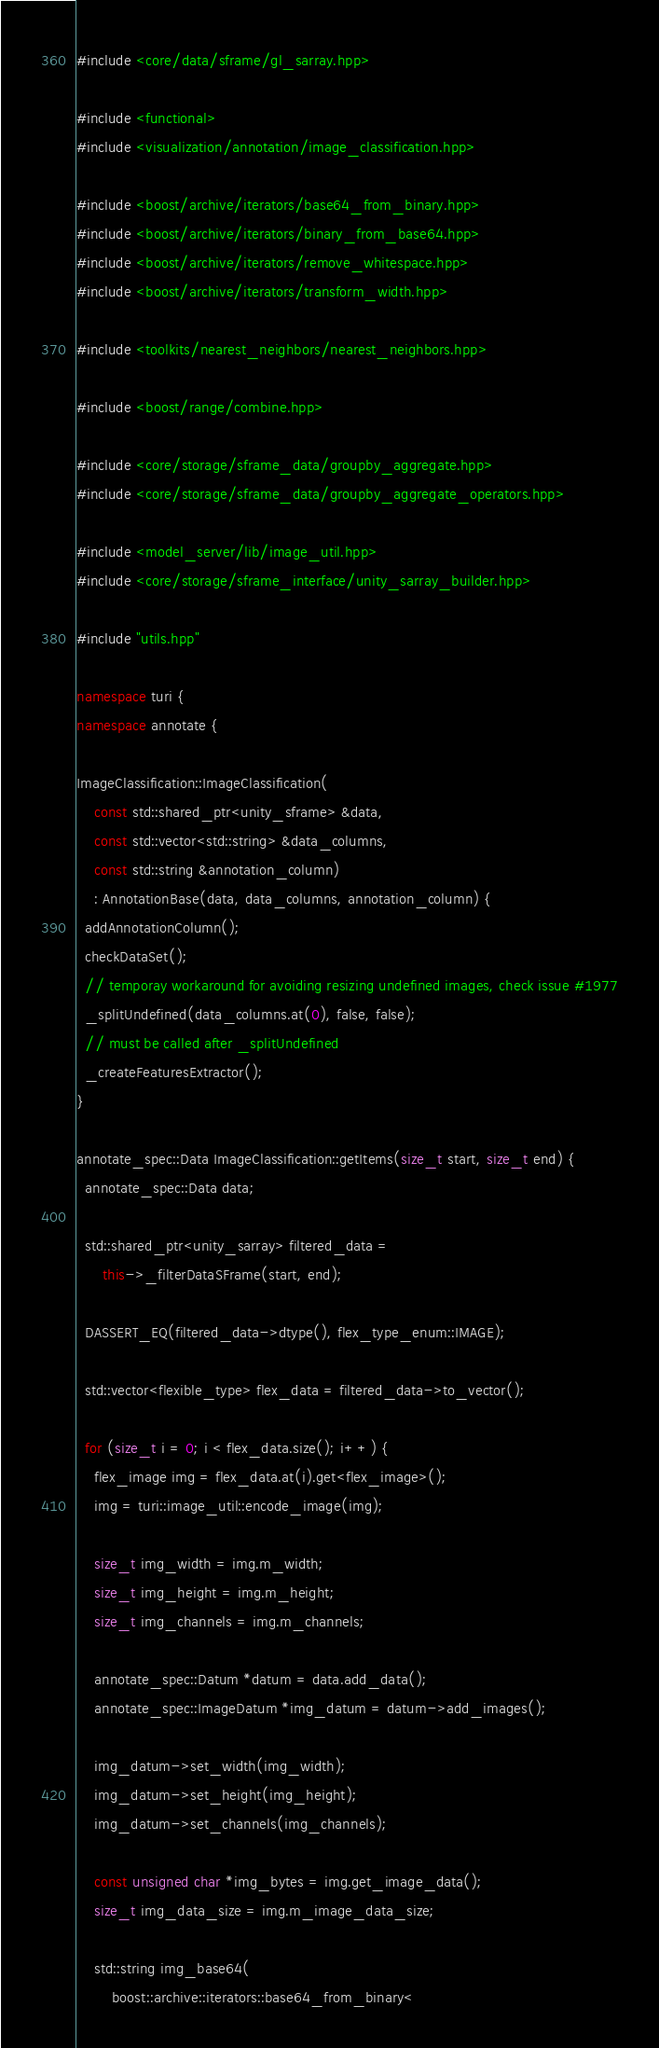Convert code to text. <code><loc_0><loc_0><loc_500><loc_500><_C++_>#include <core/data/sframe/gl_sarray.hpp>

#include <functional>
#include <visualization/annotation/image_classification.hpp>

#include <boost/archive/iterators/base64_from_binary.hpp>
#include <boost/archive/iterators/binary_from_base64.hpp>
#include <boost/archive/iterators/remove_whitespace.hpp>
#include <boost/archive/iterators/transform_width.hpp>

#include <toolkits/nearest_neighbors/nearest_neighbors.hpp>

#include <boost/range/combine.hpp>

#include <core/storage/sframe_data/groupby_aggregate.hpp>
#include <core/storage/sframe_data/groupby_aggregate_operators.hpp>

#include <model_server/lib/image_util.hpp>
#include <core/storage/sframe_interface/unity_sarray_builder.hpp>

#include "utils.hpp"

namespace turi {
namespace annotate {

ImageClassification::ImageClassification(
    const std::shared_ptr<unity_sframe> &data,
    const std::vector<std::string> &data_columns,
    const std::string &annotation_column)
    : AnnotationBase(data, data_columns, annotation_column) {
  addAnnotationColumn();
  checkDataSet();
  // temporay workaround for avoiding resizing undefined images, check issue #1977
  _splitUndefined(data_columns.at(0), false, false);
  // must be called after _splitUndefined
  _createFeaturesExtractor();
}

annotate_spec::Data ImageClassification::getItems(size_t start, size_t end) {
  annotate_spec::Data data;

  std::shared_ptr<unity_sarray> filtered_data =
      this->_filterDataSFrame(start, end);

  DASSERT_EQ(filtered_data->dtype(), flex_type_enum::IMAGE);

  std::vector<flexible_type> flex_data = filtered_data->to_vector();

  for (size_t i = 0; i < flex_data.size(); i++) {
    flex_image img = flex_data.at(i).get<flex_image>();
    img = turi::image_util::encode_image(img);

    size_t img_width = img.m_width;
    size_t img_height = img.m_height;
    size_t img_channels = img.m_channels;

    annotate_spec::Datum *datum = data.add_data();
    annotate_spec::ImageDatum *img_datum = datum->add_images();

    img_datum->set_width(img_width);
    img_datum->set_height(img_height);
    img_datum->set_channels(img_channels);

    const unsigned char *img_bytes = img.get_image_data();
    size_t img_data_size = img.m_image_data_size;

    std::string img_base64(
        boost::archive::iterators::base64_from_binary<</code> 